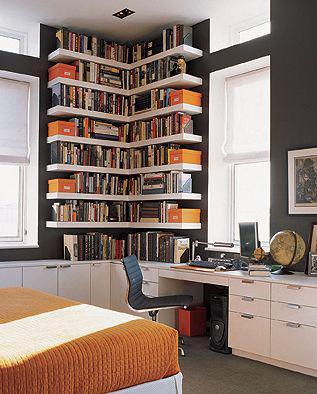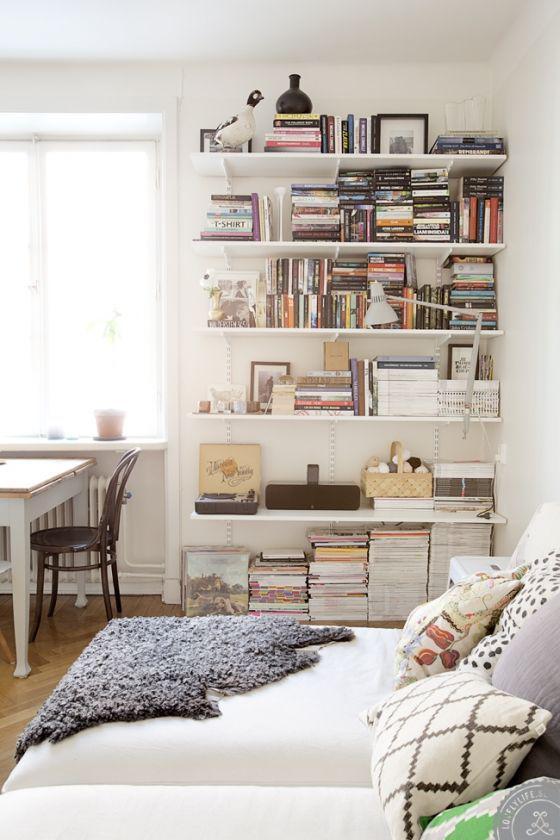The first image is the image on the left, the second image is the image on the right. For the images displayed, is the sentence "The bookshelves in at least one image are flat boards with at least one open end, with items on the shelves serving as bookends." factually correct? Answer yes or no. Yes. The first image is the image on the left, the second image is the image on the right. Examine the images to the left and right. Is the description "Left image shows traditional built-in white bookcase with a white back." accurate? Answer yes or no. No. 